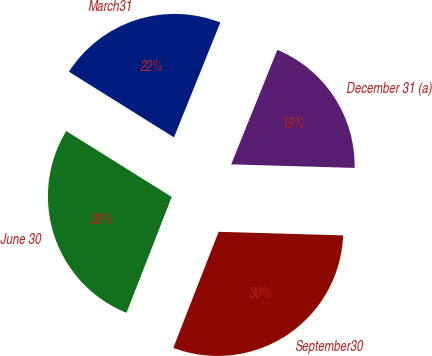Convert chart. <chart><loc_0><loc_0><loc_500><loc_500><pie_chart><fcel>March31<fcel>June 30<fcel>September30<fcel>December 31 (a)<nl><fcel>22.22%<fcel>27.96%<fcel>30.47%<fcel>19.35%<nl></chart> 